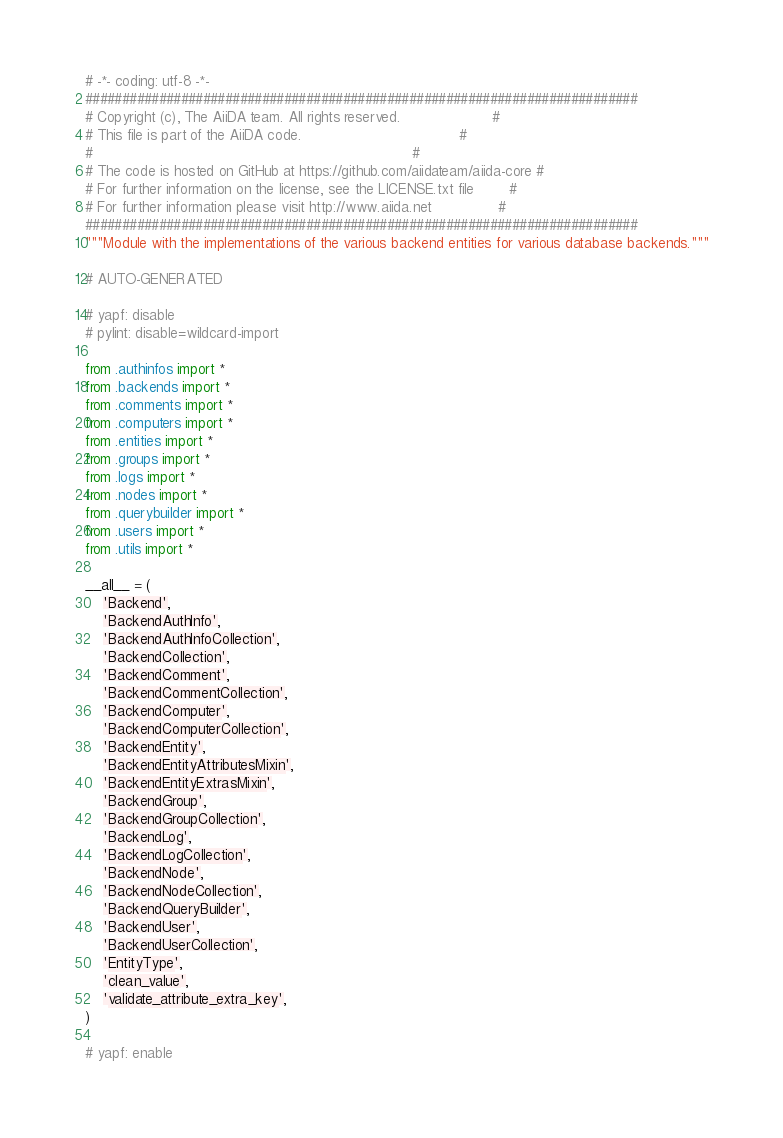Convert code to text. <code><loc_0><loc_0><loc_500><loc_500><_Python_># -*- coding: utf-8 -*-
###########################################################################
# Copyright (c), The AiiDA team. All rights reserved.                     #
# This file is part of the AiiDA code.                                    #
#                                                                         #
# The code is hosted on GitHub at https://github.com/aiidateam/aiida-core #
# For further information on the license, see the LICENSE.txt file        #
# For further information please visit http://www.aiida.net               #
###########################################################################
"""Module with the implementations of the various backend entities for various database backends."""

# AUTO-GENERATED

# yapf: disable
# pylint: disable=wildcard-import

from .authinfos import *
from .backends import *
from .comments import *
from .computers import *
from .entities import *
from .groups import *
from .logs import *
from .nodes import *
from .querybuilder import *
from .users import *
from .utils import *

__all__ = (
    'Backend',
    'BackendAuthInfo',
    'BackendAuthInfoCollection',
    'BackendCollection',
    'BackendComment',
    'BackendCommentCollection',
    'BackendComputer',
    'BackendComputerCollection',
    'BackendEntity',
    'BackendEntityAttributesMixin',
    'BackendEntityExtrasMixin',
    'BackendGroup',
    'BackendGroupCollection',
    'BackendLog',
    'BackendLogCollection',
    'BackendNode',
    'BackendNodeCollection',
    'BackendQueryBuilder',
    'BackendUser',
    'BackendUserCollection',
    'EntityType',
    'clean_value',
    'validate_attribute_extra_key',
)

# yapf: enable
</code> 